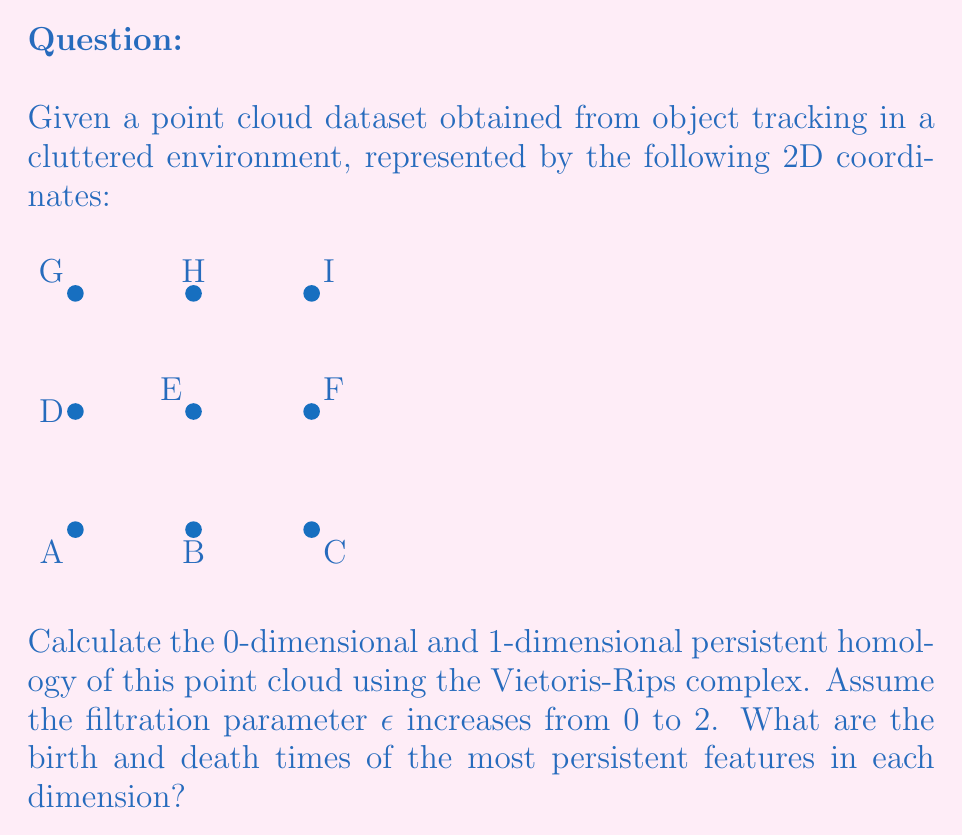Could you help me with this problem? To calculate the persistent homology, we'll follow these steps:

1) First, we need to understand what happens as $\epsilon$ increases:

   - At $\epsilon = 0$: Each point is its own connected component.
   - At $\epsilon = 1$: Points that are 1 unit apart connect, forming a grid-like structure.
   - At $\epsilon = \sqrt{2}$: Diagonal connections form, creating triangles.
   - At $\epsilon = 2$: All points connect, forming a single connected component.

2) 0-dimensional persistent homology (connected components):
   - We start with 9 components at $\epsilon = 0$.
   - At $\epsilon = 1$, we're left with 1 component as all adjacent points connect.
   - This single component persists for all larger $\epsilon$.

3) 1-dimensional persistent homology (loops):
   - No loops exist until $\epsilon = 1$.
   - At $\epsilon = 1$, four 1-dimensional loops form: ABDE, BCEF, DEHI, EFHI.
   - These loops persist until $\epsilon = \sqrt{2}$, when diagonal connections fill them in.

4) The most persistent features:
   - In 0-dimension: The single component that forms at $\epsilon = 1$ and never dies.
   - In 1-dimension: The four loops that form at $\epsilon = 1$ and die at $\epsilon = \sqrt{2}$.

Therefore, the most persistent features are:
- 0-dimension: Birth at $\epsilon = 0$, Death at $\epsilon = \infty$ (never dies)
- 1-dimension: Birth at $\epsilon = 1$, Death at $\epsilon = \sqrt{2}$
Answer: 0-dim: (0, $\infty$); 1-dim: (1, $\sqrt{2}$) 